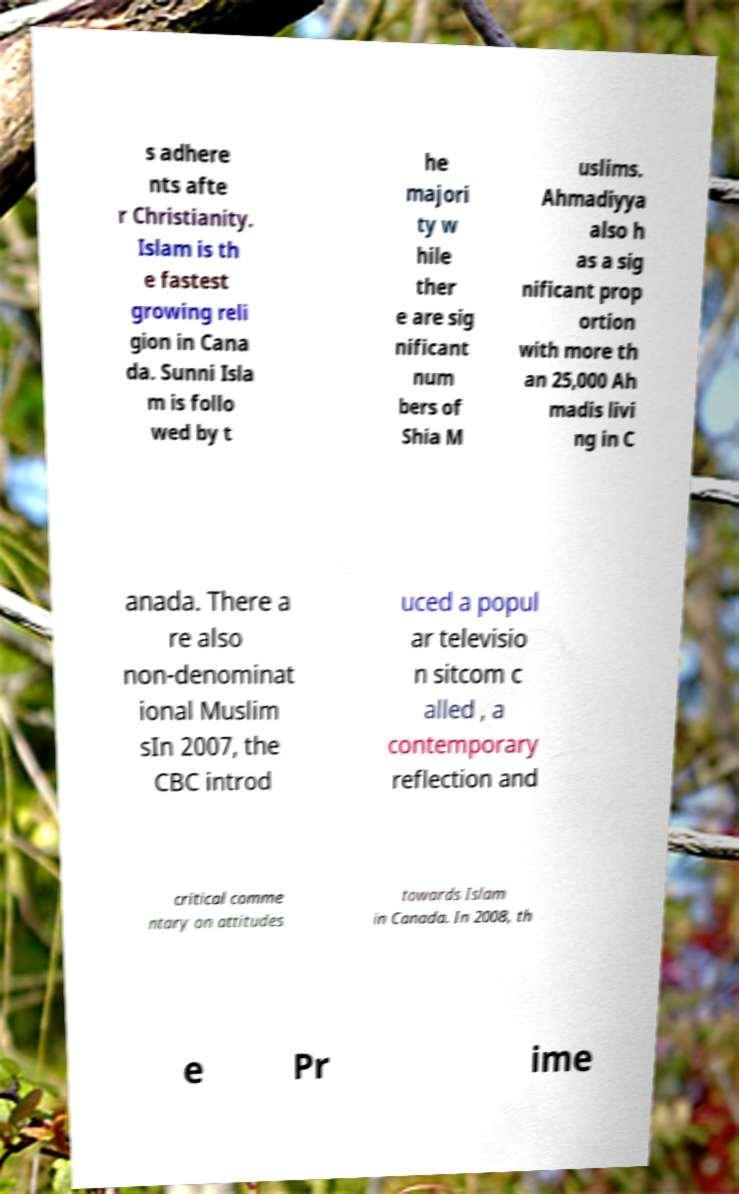For documentation purposes, I need the text within this image transcribed. Could you provide that? s adhere nts afte r Christianity. Islam is th e fastest growing reli gion in Cana da. Sunni Isla m is follo wed by t he majori ty w hile ther e are sig nificant num bers of Shia M uslims. Ahmadiyya also h as a sig nificant prop ortion with more th an 25,000 Ah madis livi ng in C anada. There a re also non-denominat ional Muslim sIn 2007, the CBC introd uced a popul ar televisio n sitcom c alled , a contemporary reflection and critical comme ntary on attitudes towards Islam in Canada. In 2008, th e Pr ime 